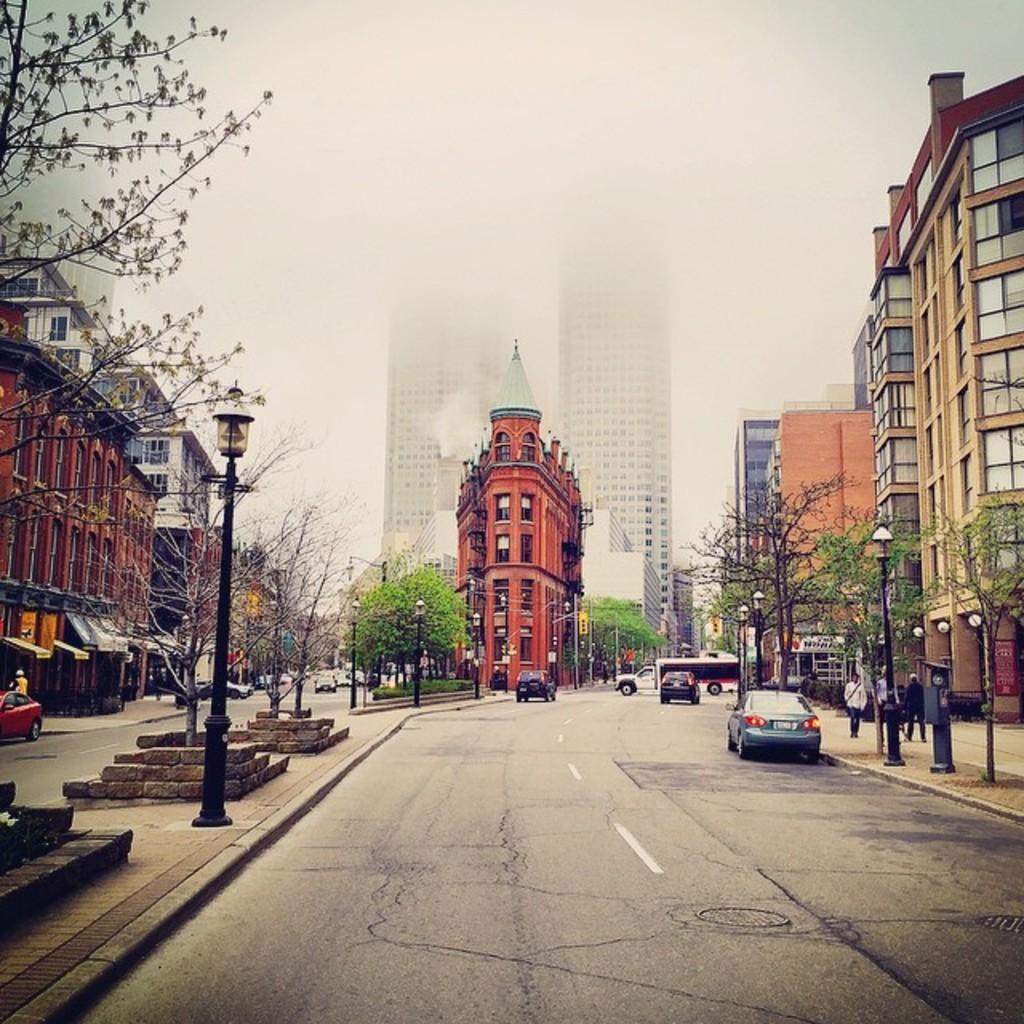Please provide a concise description of this image. In the image there is road in the middle with people with cars moving on it, on either side of it there are buildings and in the middle there are trees in front of the buildings and above its cloudy sky, on the right side there are some people walking on the footpath. 